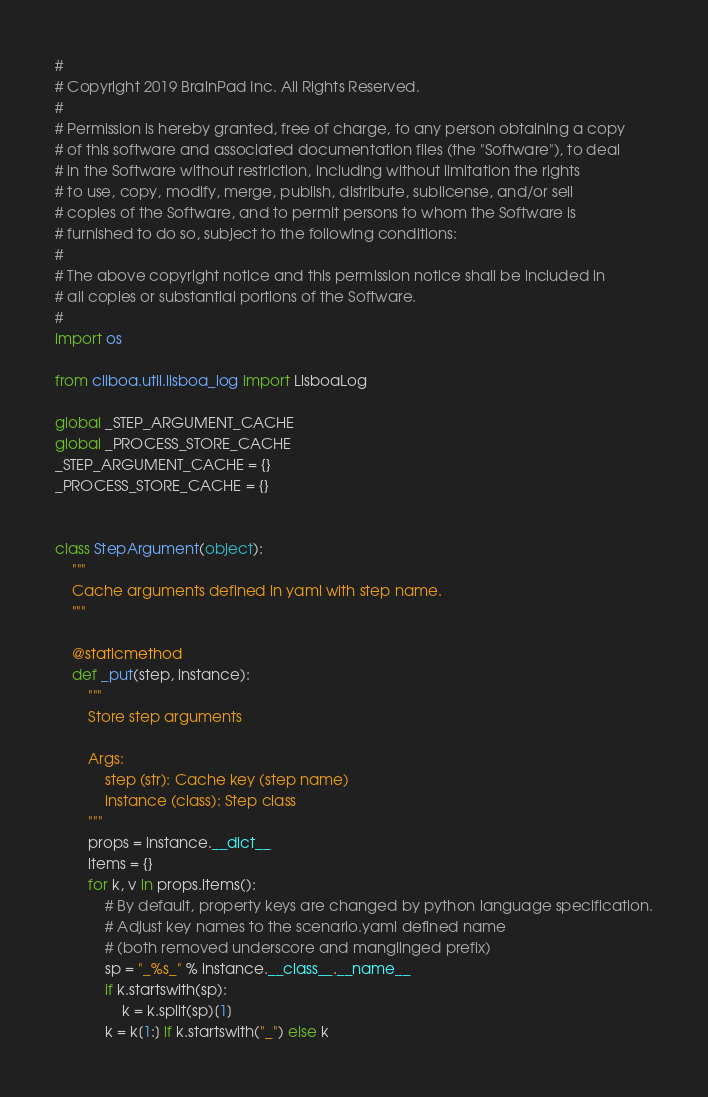<code> <loc_0><loc_0><loc_500><loc_500><_Python_>#
# Copyright 2019 BrainPad Inc. All Rights Reserved.
#
# Permission is hereby granted, free of charge, to any person obtaining a copy
# of this software and associated documentation files (the "Software"), to deal
# in the Software without restriction, including without limitation the rights
# to use, copy, modify, merge, publish, distribute, sublicense, and/or sell
# copies of the Software, and to permit persons to whom the Software is
# furnished to do so, subject to the following conditions:
#
# The above copyright notice and this permission notice shall be included in
# all copies or substantial portions of the Software.
#
import os

from cliboa.util.lisboa_log import LisboaLog

global _STEP_ARGUMENT_CACHE
global _PROCESS_STORE_CACHE
_STEP_ARGUMENT_CACHE = {}
_PROCESS_STORE_CACHE = {}


class StepArgument(object):
    """
    Cache arguments defined in yaml with step name.
    """

    @staticmethod
    def _put(step, instance):
        """
        Store step arguments

        Args:
            step (str): Cache key (step name)
            instance (class): Step class
        """
        props = instance.__dict__
        items = {}
        for k, v in props.items():
            # By default, property keys are changed by python language specification.
            # Adjust key names to the scenario.yaml defined name
            # (both removed underscore and manglinged prefix)
            sp = "_%s_" % instance.__class__.__name__
            if k.startswith(sp):
                k = k.split(sp)[1]
            k = k[1:] if k.startswith("_") else k</code> 